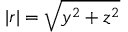<formula> <loc_0><loc_0><loc_500><loc_500>| r | = \sqrt { y ^ { 2 } + z ^ { 2 } }</formula> 